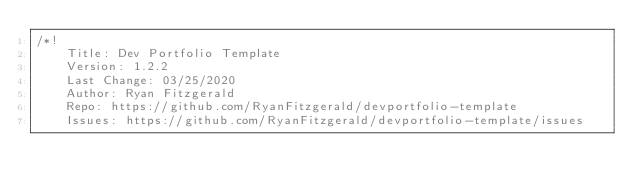<code> <loc_0><loc_0><loc_500><loc_500><_CSS_>/*!
    Title: Dev Portfolio Template
    Version: 1.2.2
    Last Change: 03/25/2020
    Author: Ryan Fitzgerald
    Repo: https://github.com/RyanFitzgerald/devportfolio-template
    Issues: https://github.com/RyanFitzgerald/devportfolio-template/issues
</code> 